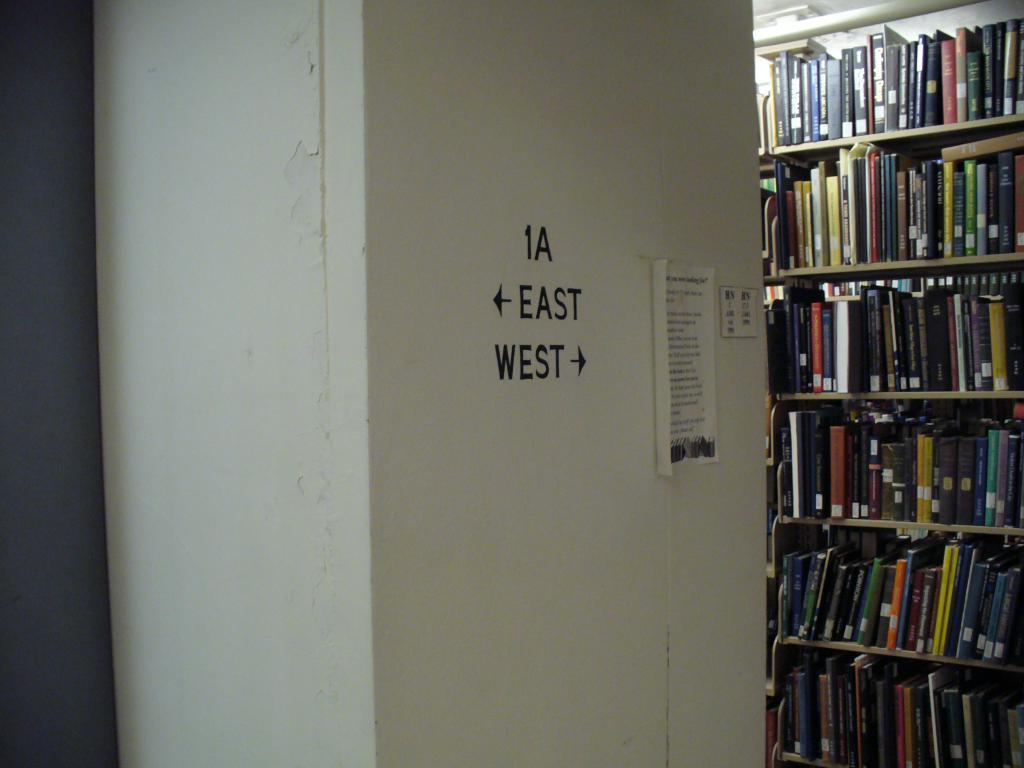What is located in the center of the image? There is a wall in the center of the image. What can be seen on the right side of the image? There is a bookshelf on the right side of the image. What is featured on the wall in the image? There is a poster on the wall. How many ducks are swimming in the bookshelf in the image? There are no ducks present in the image, and the bookshelf is not a body of water where ducks would swim. 